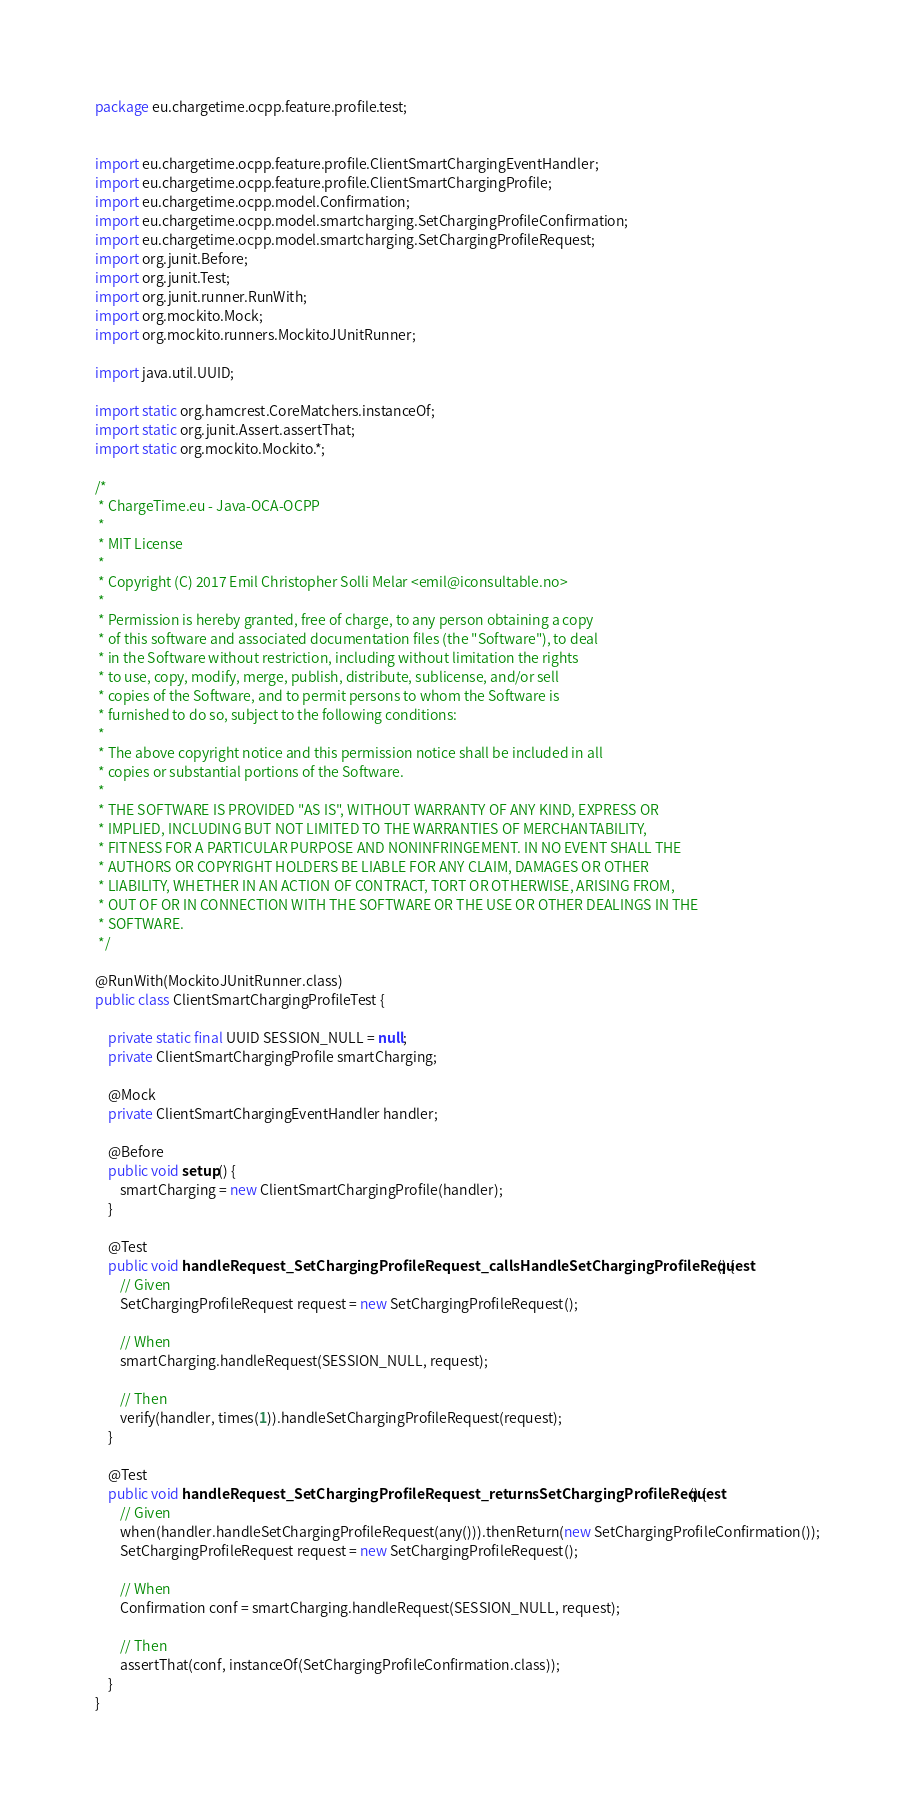<code> <loc_0><loc_0><loc_500><loc_500><_Java_>package eu.chargetime.ocpp.feature.profile.test;


import eu.chargetime.ocpp.feature.profile.ClientSmartChargingEventHandler;
import eu.chargetime.ocpp.feature.profile.ClientSmartChargingProfile;
import eu.chargetime.ocpp.model.Confirmation;
import eu.chargetime.ocpp.model.smartcharging.SetChargingProfileConfirmation;
import eu.chargetime.ocpp.model.smartcharging.SetChargingProfileRequest;
import org.junit.Before;
import org.junit.Test;
import org.junit.runner.RunWith;
import org.mockito.Mock;
import org.mockito.runners.MockitoJUnitRunner;

import java.util.UUID;

import static org.hamcrest.CoreMatchers.instanceOf;
import static org.junit.Assert.assertThat;
import static org.mockito.Mockito.*;

/*
 * ChargeTime.eu - Java-OCA-OCPP
 *
 * MIT License
 *
 * Copyright (C) 2017 Emil Christopher Solli Melar <emil@iconsultable.no>
 *
 * Permission is hereby granted, free of charge, to any person obtaining a copy
 * of this software and associated documentation files (the "Software"), to deal
 * in the Software without restriction, including without limitation the rights
 * to use, copy, modify, merge, publish, distribute, sublicense, and/or sell
 * copies of the Software, and to permit persons to whom the Software is
 * furnished to do so, subject to the following conditions:
 *
 * The above copyright notice and this permission notice shall be included in all
 * copies or substantial portions of the Software.
 *
 * THE SOFTWARE IS PROVIDED "AS IS", WITHOUT WARRANTY OF ANY KIND, EXPRESS OR
 * IMPLIED, INCLUDING BUT NOT LIMITED TO THE WARRANTIES OF MERCHANTABILITY,
 * FITNESS FOR A PARTICULAR PURPOSE AND NONINFRINGEMENT. IN NO EVENT SHALL THE
 * AUTHORS OR COPYRIGHT HOLDERS BE LIABLE FOR ANY CLAIM, DAMAGES OR OTHER
 * LIABILITY, WHETHER IN AN ACTION OF CONTRACT, TORT OR OTHERWISE, ARISING FROM,
 * OUT OF OR IN CONNECTION WITH THE SOFTWARE OR THE USE OR OTHER DEALINGS IN THE
 * SOFTWARE.
 */

@RunWith(MockitoJUnitRunner.class)
public class ClientSmartChargingProfileTest {

    private static final UUID SESSION_NULL = null;
    private ClientSmartChargingProfile smartCharging;

    @Mock
    private ClientSmartChargingEventHandler handler;

    @Before
    public void setup() {
        smartCharging = new ClientSmartChargingProfile(handler);
    }

    @Test
    public void handleRequest_SetChargingProfileRequest_callsHandleSetChargingProfileRequest() {
        // Given
        SetChargingProfileRequest request = new SetChargingProfileRequest();

        // When
        smartCharging.handleRequest(SESSION_NULL, request);

        // Then
        verify(handler, times(1)).handleSetChargingProfileRequest(request);
    }

    @Test
    public void handleRequest_SetChargingProfileRequest_returnsSetChargingProfileRequest() {
        // Given
        when(handler.handleSetChargingProfileRequest(any())).thenReturn(new SetChargingProfileConfirmation());
        SetChargingProfileRequest request = new SetChargingProfileRequest();

        // When
        Confirmation conf = smartCharging.handleRequest(SESSION_NULL, request);

        // Then
        assertThat(conf, instanceOf(SetChargingProfileConfirmation.class));
    }
}
</code> 